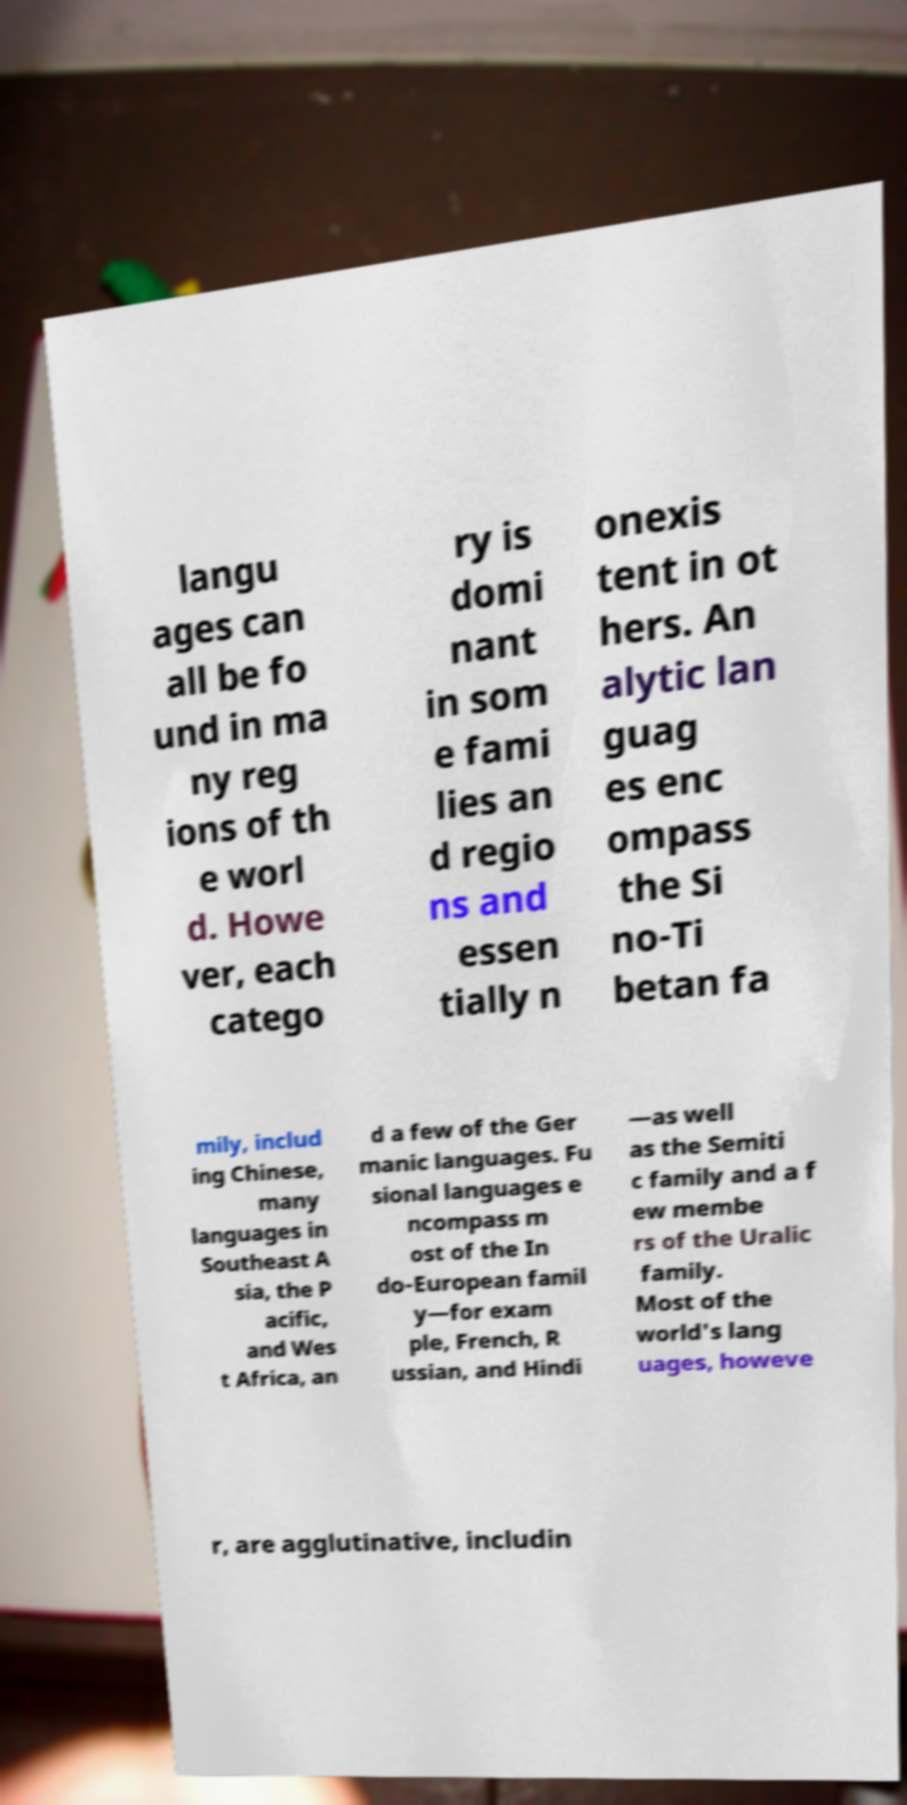Can you accurately transcribe the text from the provided image for me? langu ages can all be fo und in ma ny reg ions of th e worl d. Howe ver, each catego ry is domi nant in som e fami lies an d regio ns and essen tially n onexis tent in ot hers. An alytic lan guag es enc ompass the Si no-Ti betan fa mily, includ ing Chinese, many languages in Southeast A sia, the P acific, and Wes t Africa, an d a few of the Ger manic languages. Fu sional languages e ncompass m ost of the In do-European famil y—for exam ple, French, R ussian, and Hindi —as well as the Semiti c family and a f ew membe rs of the Uralic family. Most of the world's lang uages, howeve r, are agglutinative, includin 